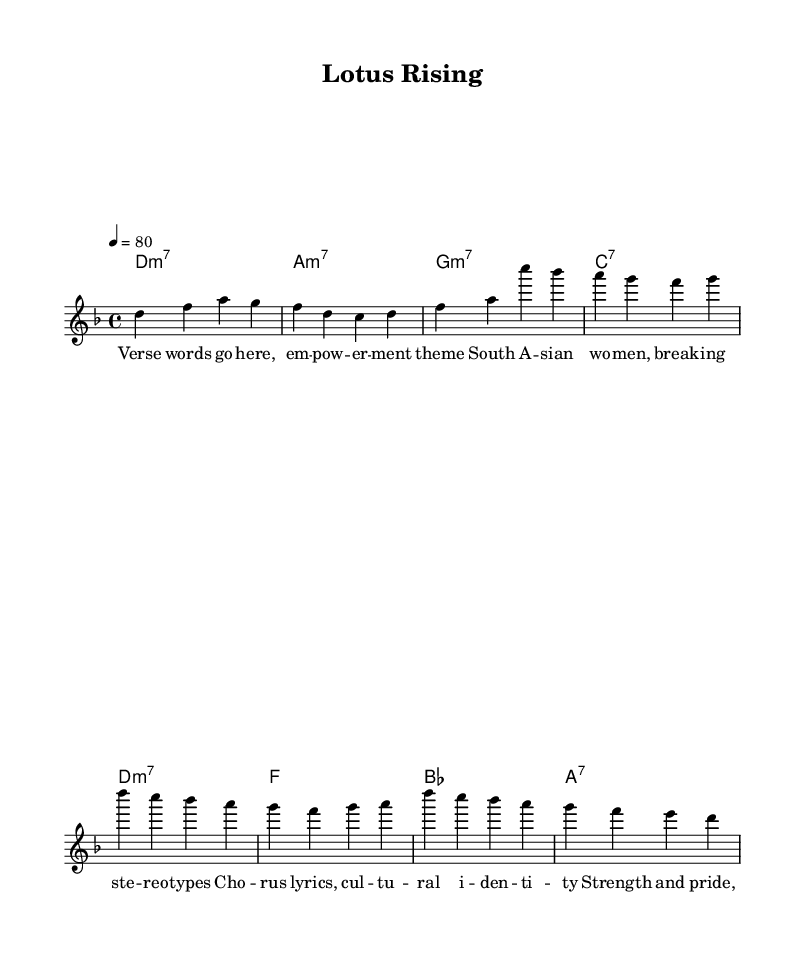What is the key signature of this music? The key signature indicated in the global section is D minor, which has one flat (B flat).
Answer: D minor What is the time signature of this music? The time signature is found in the global section, which shows 4/4 time, meaning there are four beats per measure.
Answer: 4/4 What is the tempo marking of this piece? The tempo marking indicates that the piece should be played at 80 beats per minute, as noted in the global section.
Answer: 80 How many measures are in the verse? The verse consists of two lines of melody; each line has four measures. Therefore, there are a total of 8 measures in the verse.
Answer: 8 What is the main theme reflected in the lyrics? The lyrics discuss empowerment and breaking stereotypes, focusing on South Asian women, which suggests cultural identity and female empowerment are central themes.
Answer: Empowerment What is the structure of the song demonstrated in the score? The score shows a common structure with a verse followed by a chorus. The verse has its own set of lyrics and is then repeated by the chorus, showcasing a typical soul structure.
Answer: Verse-Chorus What unique aspect of modern neo-soul is present in this piece? The piece blends contemporary musical elements with themes of cultural identity and female empowerment, typical of modern neo-soul and characterizing personal and cultural narratives.
Answer: Cultural identity 